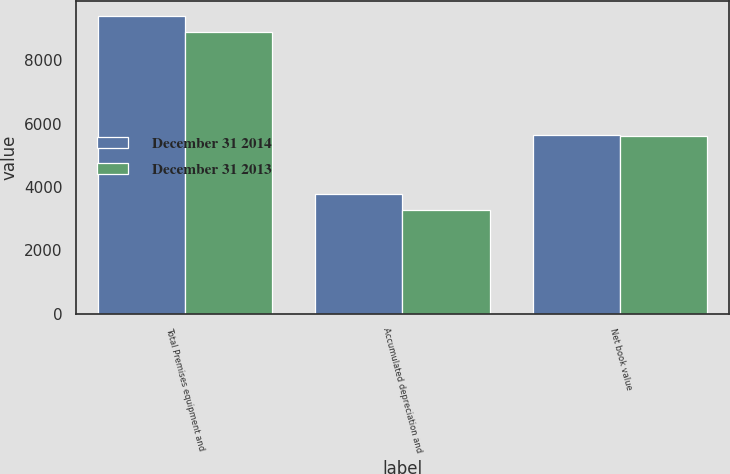Convert chart. <chart><loc_0><loc_0><loc_500><loc_500><stacked_bar_chart><ecel><fcel>Total Premises equipment and<fcel>Accumulated depreciation and<fcel>Net book value<nl><fcel>December 31 2014<fcel>9416<fcel>3773<fcel>5643<nl><fcel>December 31 2013<fcel>8903<fcel>3285<fcel>5618<nl></chart> 